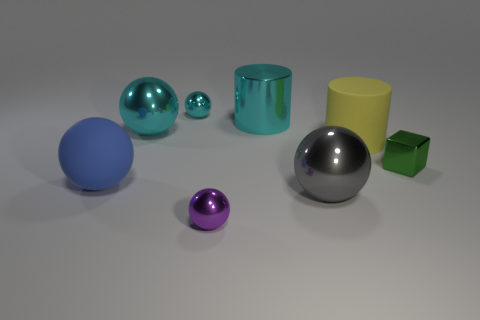Subtract all purple spheres. How many spheres are left? 4 Subtract 1 balls. How many balls are left? 4 Add 1 tiny green things. How many objects exist? 9 Subtract all cylinders. How many objects are left? 6 Add 5 big gray shiny objects. How many big gray shiny objects are left? 6 Add 7 large gray metallic objects. How many large gray metallic objects exist? 8 Subtract 0 yellow spheres. How many objects are left? 8 Subtract all yellow matte things. Subtract all large spheres. How many objects are left? 4 